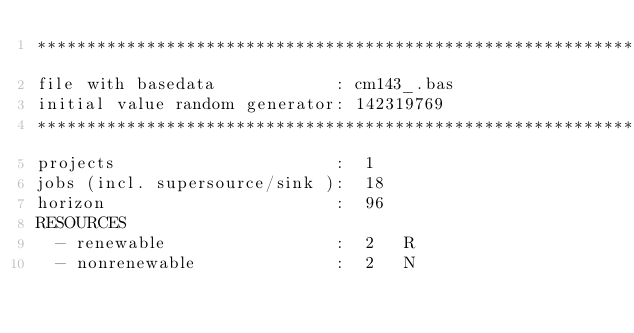Convert code to text. <code><loc_0><loc_0><loc_500><loc_500><_ObjectiveC_>************************************************************************
file with basedata            : cm143_.bas
initial value random generator: 142319769
************************************************************************
projects                      :  1
jobs (incl. supersource/sink ):  18
horizon                       :  96
RESOURCES
  - renewable                 :  2   R
  - nonrenewable              :  2   N</code> 